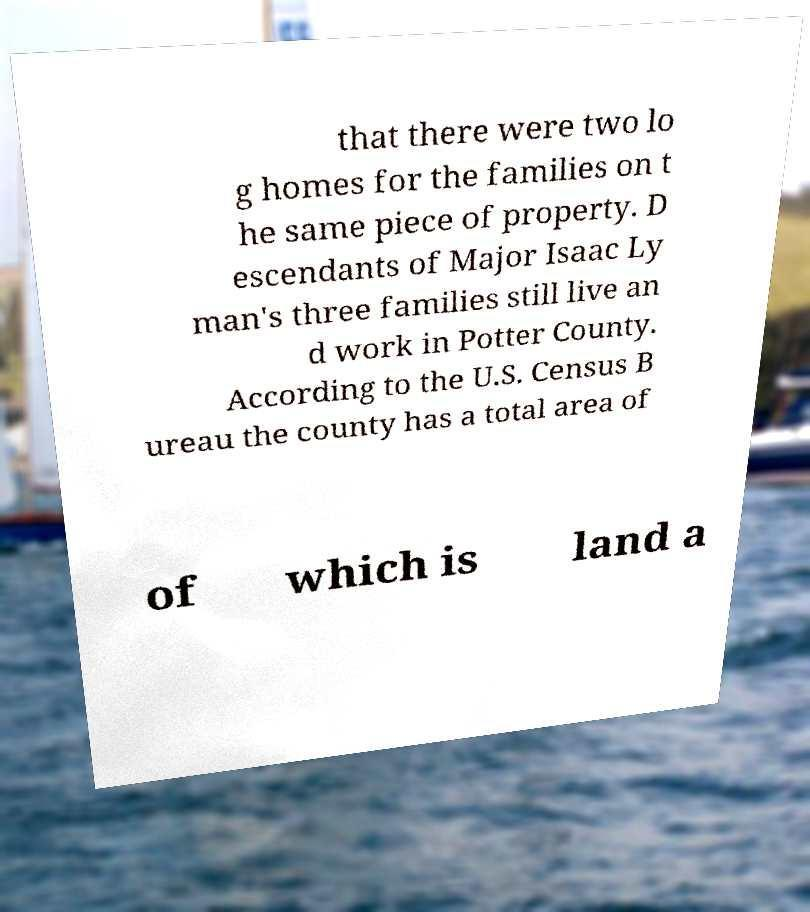There's text embedded in this image that I need extracted. Can you transcribe it verbatim? that there were two lo g homes for the families on t he same piece of property. D escendants of Major Isaac Ly man's three families still live an d work in Potter County. According to the U.S. Census B ureau the county has a total area of of which is land a 